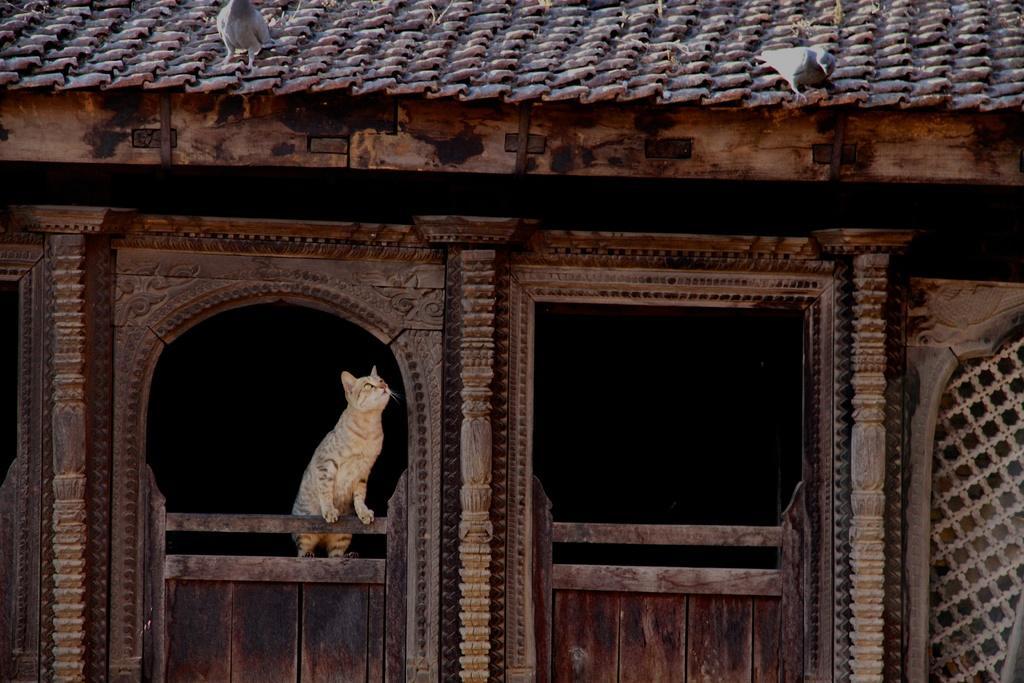Can you describe this image briefly? In this picture we can see a cat standing on wall and pigeons on a rooftop. 